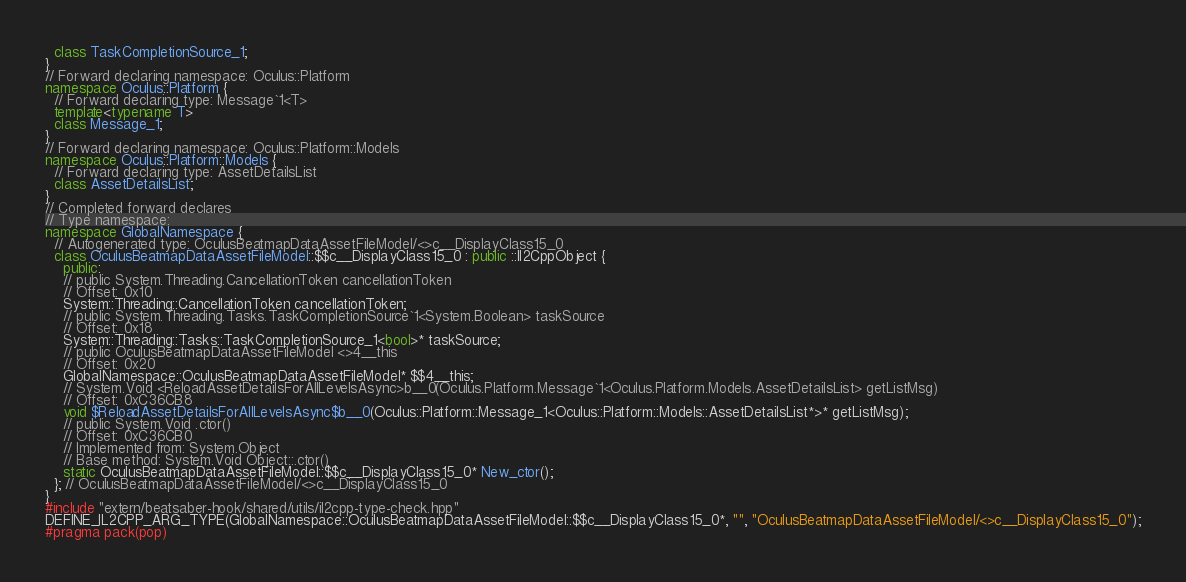<code> <loc_0><loc_0><loc_500><loc_500><_C++_>  class TaskCompletionSource_1;
}
// Forward declaring namespace: Oculus::Platform
namespace Oculus::Platform {
  // Forward declaring type: Message`1<T>
  template<typename T>
  class Message_1;
}
// Forward declaring namespace: Oculus::Platform::Models
namespace Oculus::Platform::Models {
  // Forward declaring type: AssetDetailsList
  class AssetDetailsList;
}
// Completed forward declares
// Type namespace: 
namespace GlobalNamespace {
  // Autogenerated type: OculusBeatmapDataAssetFileModel/<>c__DisplayClass15_0
  class OculusBeatmapDataAssetFileModel::$$c__DisplayClass15_0 : public ::Il2CppObject {
    public:
    // public System.Threading.CancellationToken cancellationToken
    // Offset: 0x10
    System::Threading::CancellationToken cancellationToken;
    // public System.Threading.Tasks.TaskCompletionSource`1<System.Boolean> taskSource
    // Offset: 0x18
    System::Threading::Tasks::TaskCompletionSource_1<bool>* taskSource;
    // public OculusBeatmapDataAssetFileModel <>4__this
    // Offset: 0x20
    GlobalNamespace::OculusBeatmapDataAssetFileModel* $$4__this;
    // System.Void <ReloadAssetDetailsForAllLevelsAsync>b__0(Oculus.Platform.Message`1<Oculus.Platform.Models.AssetDetailsList> getListMsg)
    // Offset: 0xC36CB8
    void $ReloadAssetDetailsForAllLevelsAsync$b__0(Oculus::Platform::Message_1<Oculus::Platform::Models::AssetDetailsList*>* getListMsg);
    // public System.Void .ctor()
    // Offset: 0xC36CB0
    // Implemented from: System.Object
    // Base method: System.Void Object::.ctor()
    static OculusBeatmapDataAssetFileModel::$$c__DisplayClass15_0* New_ctor();
  }; // OculusBeatmapDataAssetFileModel/<>c__DisplayClass15_0
}
#include "extern/beatsaber-hook/shared/utils/il2cpp-type-check.hpp"
DEFINE_IL2CPP_ARG_TYPE(GlobalNamespace::OculusBeatmapDataAssetFileModel::$$c__DisplayClass15_0*, "", "OculusBeatmapDataAssetFileModel/<>c__DisplayClass15_0");
#pragma pack(pop)
</code> 